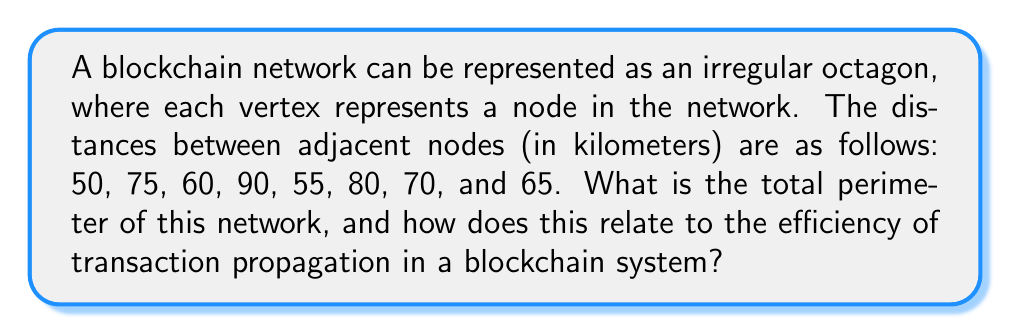Show me your answer to this math problem. To solve this problem, we need to follow these steps:

1. Identify the given information:
   - The shape is an irregular octagon
   - We have 8 side lengths: 50, 75, 60, 90, 55, 80, 70, and 65 km

2. Calculate the perimeter:
   The perimeter of a polygon is the sum of all its side lengths.

   $$P = \sum_{i=1}^{8} s_i$$

   Where $P$ is the perimeter and $s_i$ are the side lengths.

3. Sum up all the given side lengths:
   $$P = 50 + 75 + 60 + 90 + 55 + 80 + 70 + 65$$

4. Perform the addition:
   $$P = 545 \text{ km}$$

5. Interpretation for blockchain networks:
   In a blockchain network, the perimeter can be interpreted as the total distance that a transaction needs to travel to reach all nodes. A smaller perimeter generally indicates a more compact network, which could lead to faster transaction propagation and validation times. However, it's important to note that in real blockchain networks, the efficiency of transaction propagation depends on various factors beyond just physical distance, such as network bandwidth, node processing power, and the consensus mechanism used.

[asy]
unitsize(2cm);
pair A = (0,0);
pair B = (2,0);
pair C = (3,1);
pair D = (2.5,2);
pair E = (1,2.5);
pair F = (-0.5,2);
pair G = (-1,1);
pair H = (-0.5,0.5);

draw(A--B--C--D--E--F--G--H--cycle);

label("50", (A+B)/2, S);
label("75", (B+C)/2, SE);
label("60", (C+D)/2, E);
label("90", (D+E)/2, NE);
label("55", (E+F)/2, N);
label("80", (F+G)/2, NW);
label("70", (G+H)/2, W);
label("65", (H+A)/2, SW);

dot(A); dot(B); dot(C); dot(D); dot(E); dot(F); dot(G); dot(H);
[/asy]
Answer: 545 km 